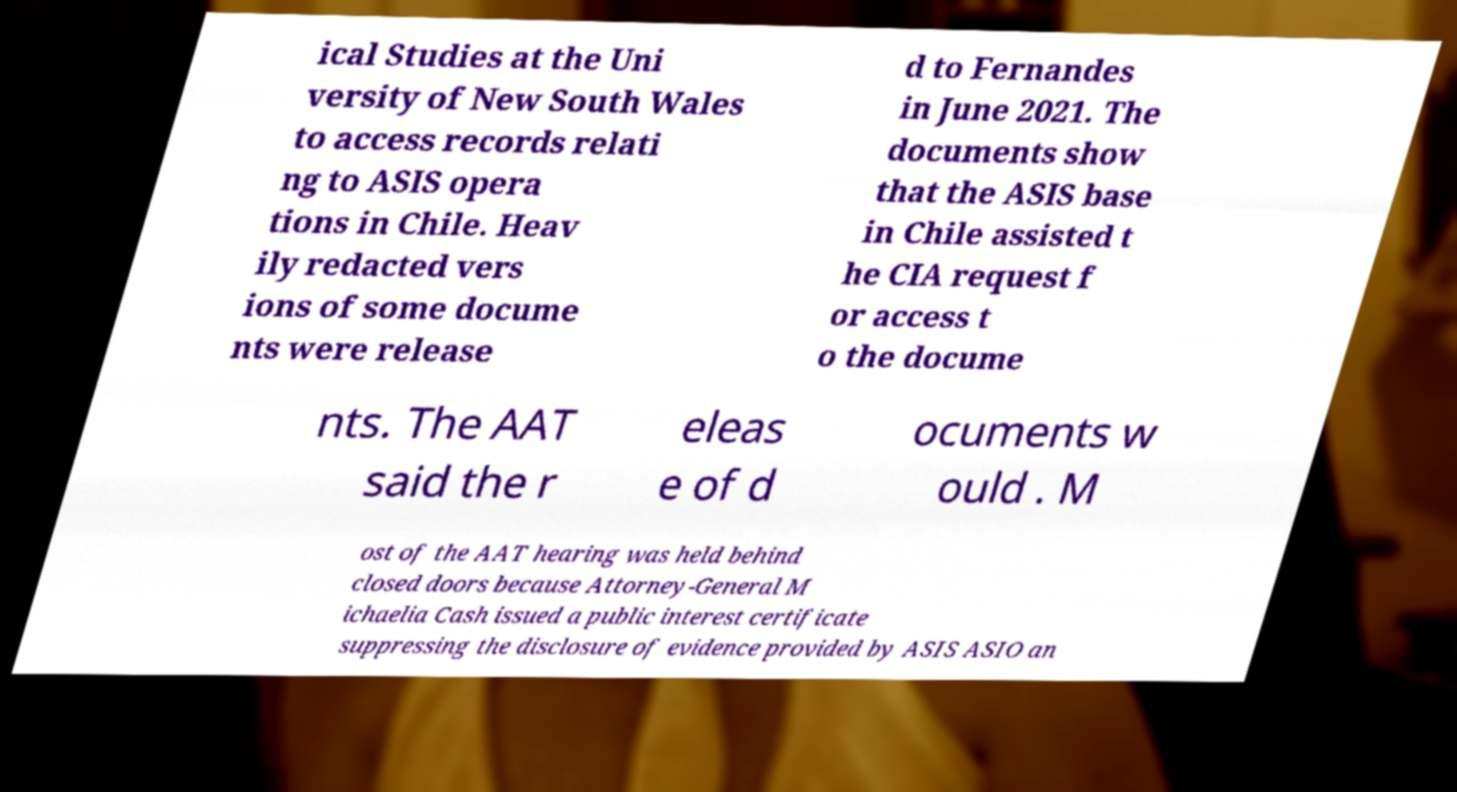There's text embedded in this image that I need extracted. Can you transcribe it verbatim? ical Studies at the Uni versity of New South Wales to access records relati ng to ASIS opera tions in Chile. Heav ily redacted vers ions of some docume nts were release d to Fernandes in June 2021. The documents show that the ASIS base in Chile assisted t he CIA request f or access t o the docume nts. The AAT said the r eleas e of d ocuments w ould . M ost of the AAT hearing was held behind closed doors because Attorney-General M ichaelia Cash issued a public interest certificate suppressing the disclosure of evidence provided by ASIS ASIO an 